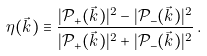<formula> <loc_0><loc_0><loc_500><loc_500>\eta ( \vec { k } ) \equiv \frac { | \mathcal { P } _ { + } ( \vec { k } ) | ^ { 2 } - | \mathcal { P } _ { - } ( \vec { k } ) | ^ { 2 } } { | \mathcal { P } _ { + } ( \vec { k } ) | ^ { 2 } + | \mathcal { P } _ { - } ( \vec { k } ) | ^ { 2 } } \, .</formula> 